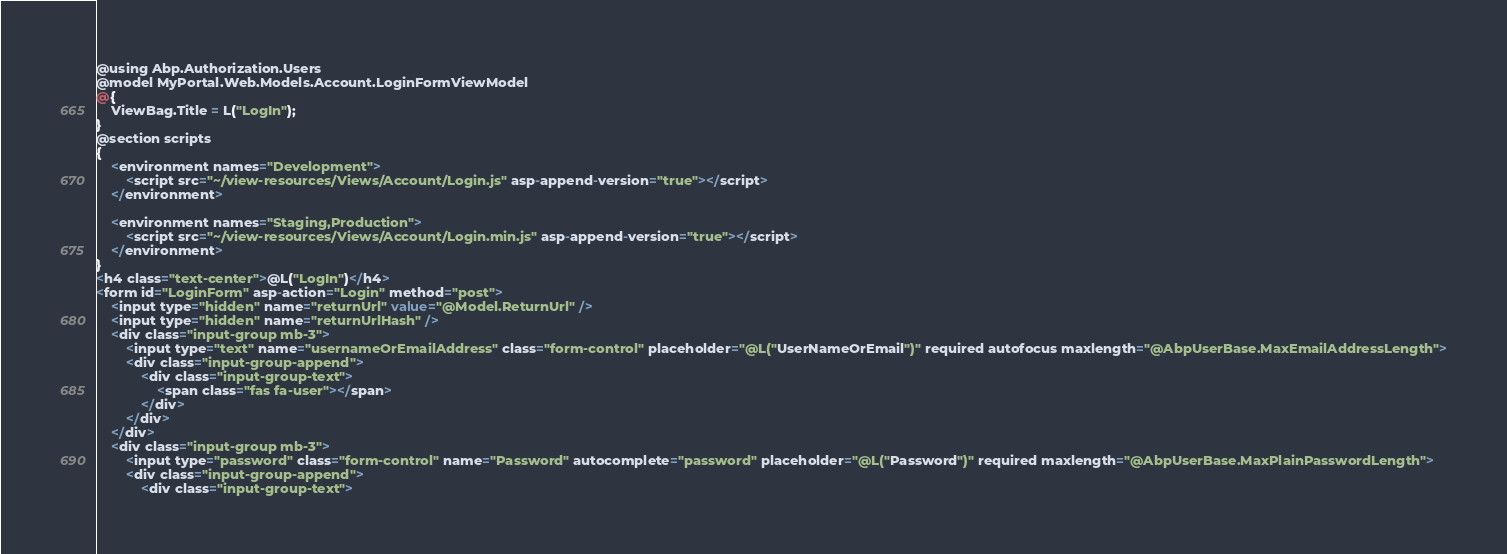<code> <loc_0><loc_0><loc_500><loc_500><_C#_>@using Abp.Authorization.Users
@model MyPortal.Web.Models.Account.LoginFormViewModel
@{
    ViewBag.Title = L("LogIn");
}
@section scripts
{
    <environment names="Development">
        <script src="~/view-resources/Views/Account/Login.js" asp-append-version="true"></script>
    </environment>

    <environment names="Staging,Production">
        <script src="~/view-resources/Views/Account/Login.min.js" asp-append-version="true"></script>
    </environment>
}
<h4 class="text-center">@L("LogIn")</h4>
<form id="LoginForm" asp-action="Login" method="post">
    <input type="hidden" name="returnUrl" value="@Model.ReturnUrl" />
    <input type="hidden" name="returnUrlHash" />
    <div class="input-group mb-3">
        <input type="text" name="usernameOrEmailAddress" class="form-control" placeholder="@L("UserNameOrEmail")" required autofocus maxlength="@AbpUserBase.MaxEmailAddressLength">
        <div class="input-group-append">
            <div class="input-group-text">
                <span class="fas fa-user"></span>
            </div>
        </div>
    </div>
    <div class="input-group mb-3">
        <input type="password" class="form-control" name="Password" autocomplete="password" placeholder="@L("Password")" required maxlength="@AbpUserBase.MaxPlainPasswordLength">
        <div class="input-group-append">
            <div class="input-group-text"></code> 